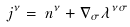<formula> <loc_0><loc_0><loc_500><loc_500>j ^ { \nu } = \, n ^ { \nu } + \nabla _ { \sigma } \/ \lambda ^ { \nu \sigma }</formula> 